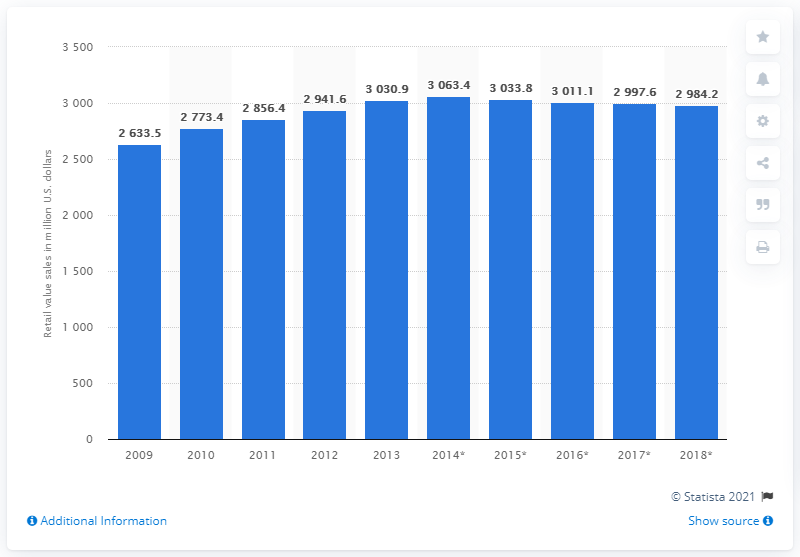Outline some significant characteristics in this image. In the year 2013, the retail sales value of yogurt and sour milk products in the United States was approximately 2984.2 million dollars. 